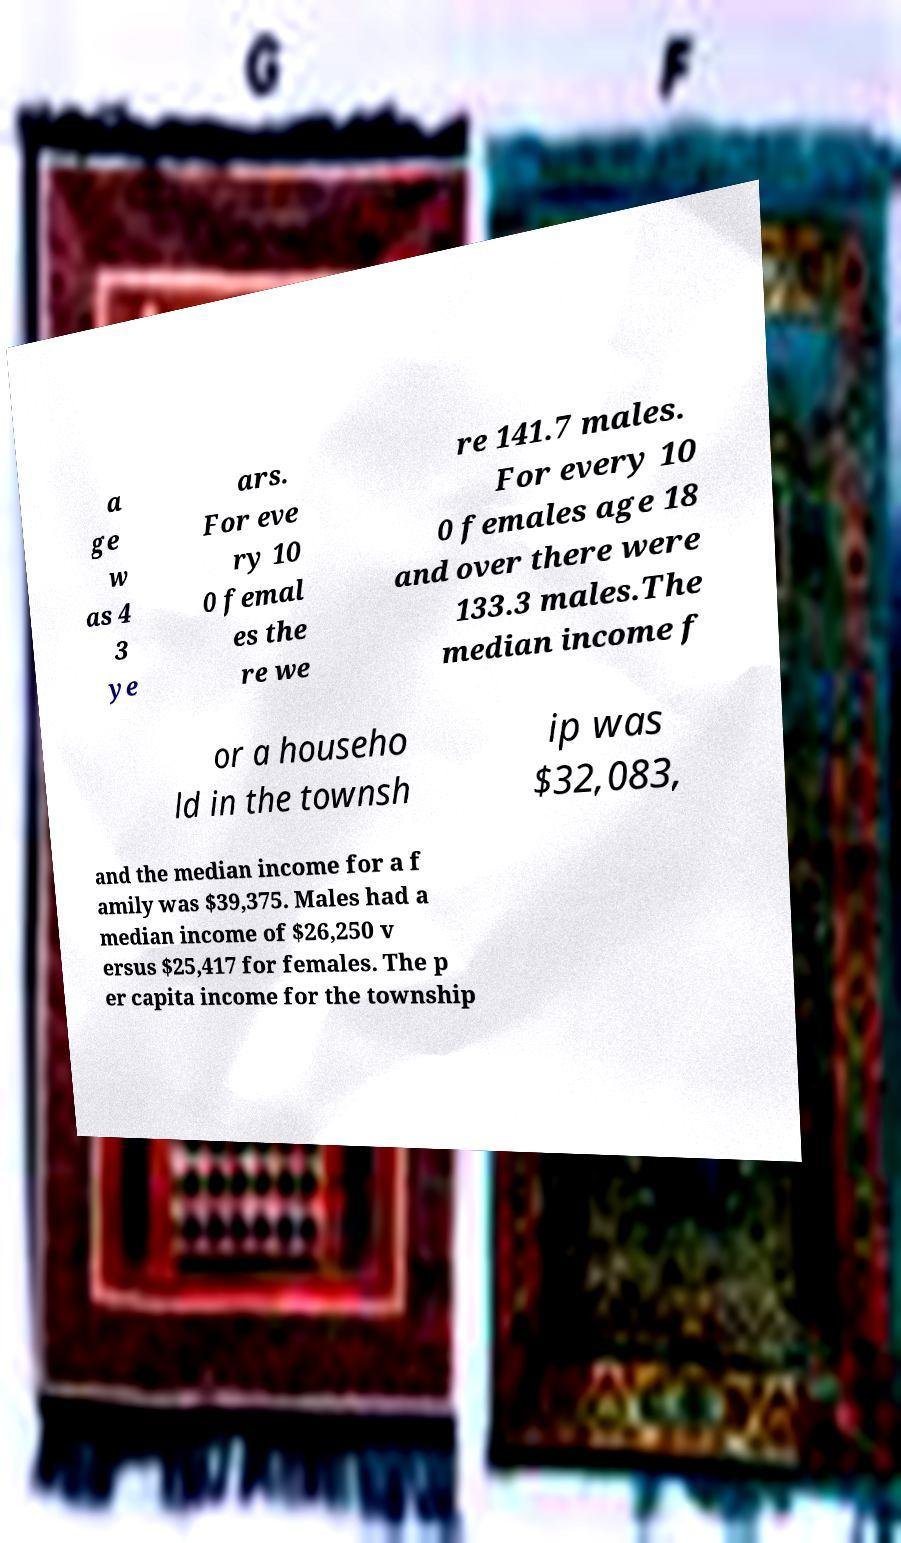What messages or text are displayed in this image? I need them in a readable, typed format. a ge w as 4 3 ye ars. For eve ry 10 0 femal es the re we re 141.7 males. For every 10 0 females age 18 and over there were 133.3 males.The median income f or a househo ld in the townsh ip was $32,083, and the median income for a f amily was $39,375. Males had a median income of $26,250 v ersus $25,417 for females. The p er capita income for the township 